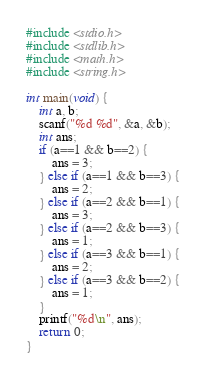<code> <loc_0><loc_0><loc_500><loc_500><_C_>#include <stdio.h>
#include <stdlib.h>
#include <math.h>
#include <string.h>

int main(void) {
    int a, b;
    scanf("%d %d", &a, &b);
    int ans;
    if (a==1 && b==2) {
        ans = 3;
    } else if (a==1 && b==3) {
        ans = 2;
    } else if (a==2 && b==1) {
        ans = 3;
    } else if (a==2 && b==3) {
        ans = 1;
    } else if (a==3 && b==1) {
        ans = 2;
    } else if (a==3 && b==2) {
        ans = 1;
    }
    printf("%d\n", ans);
    return 0;
}
</code> 